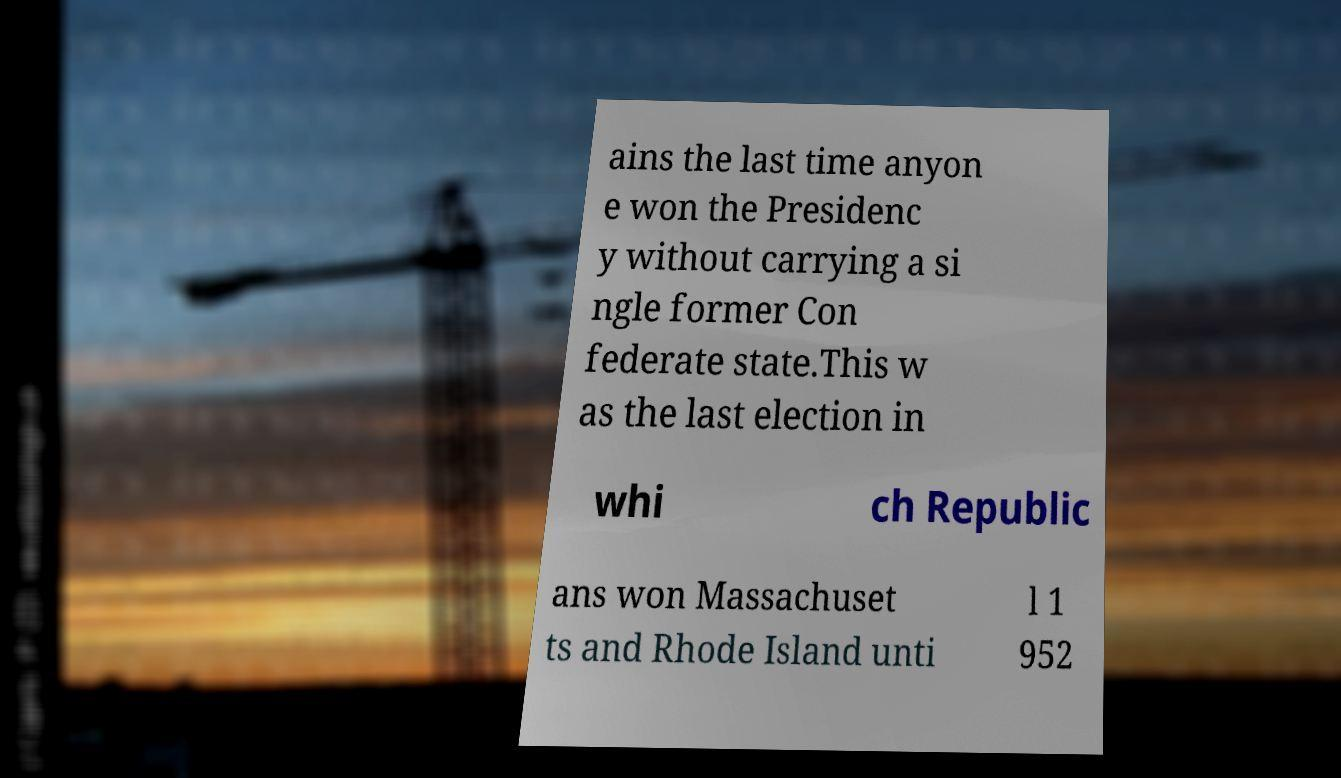Please read and relay the text visible in this image. What does it say? ains the last time anyon e won the Presidenc y without carrying a si ngle former Con federate state.This w as the last election in whi ch Republic ans won Massachuset ts and Rhode Island unti l 1 952 